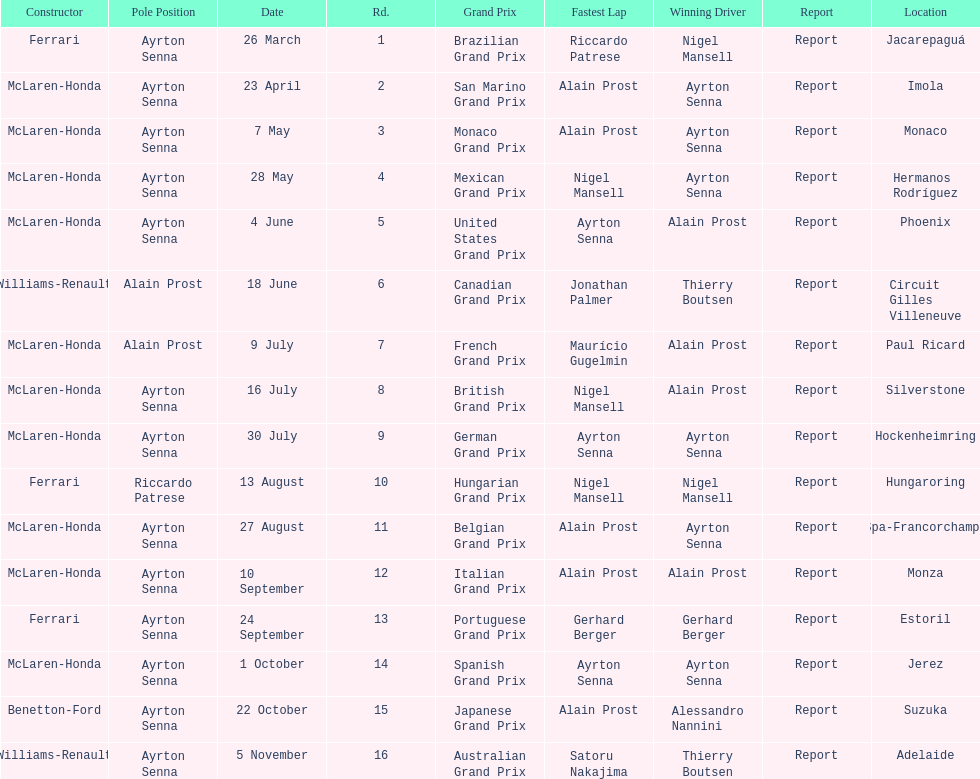Would you mind parsing the complete table? {'header': ['Constructor', 'Pole Position', 'Date', 'Rd.', 'Grand Prix', 'Fastest Lap', 'Winning Driver', 'Report', 'Location'], 'rows': [['Ferrari', 'Ayrton Senna', '26 March', '1', 'Brazilian Grand Prix', 'Riccardo Patrese', 'Nigel Mansell', 'Report', 'Jacarepaguá'], ['McLaren-Honda', 'Ayrton Senna', '23 April', '2', 'San Marino Grand Prix', 'Alain Prost', 'Ayrton Senna', 'Report', 'Imola'], ['McLaren-Honda', 'Ayrton Senna', '7 May', '3', 'Monaco Grand Prix', 'Alain Prost', 'Ayrton Senna', 'Report', 'Monaco'], ['McLaren-Honda', 'Ayrton Senna', '28 May', '4', 'Mexican Grand Prix', 'Nigel Mansell', 'Ayrton Senna', 'Report', 'Hermanos Rodríguez'], ['McLaren-Honda', 'Ayrton Senna', '4 June', '5', 'United States Grand Prix', 'Ayrton Senna', 'Alain Prost', 'Report', 'Phoenix'], ['Williams-Renault', 'Alain Prost', '18 June', '6', 'Canadian Grand Prix', 'Jonathan Palmer', 'Thierry Boutsen', 'Report', 'Circuit Gilles Villeneuve'], ['McLaren-Honda', 'Alain Prost', '9 July', '7', 'French Grand Prix', 'Maurício Gugelmin', 'Alain Prost', 'Report', 'Paul Ricard'], ['McLaren-Honda', 'Ayrton Senna', '16 July', '8', 'British Grand Prix', 'Nigel Mansell', 'Alain Prost', 'Report', 'Silverstone'], ['McLaren-Honda', 'Ayrton Senna', '30 July', '9', 'German Grand Prix', 'Ayrton Senna', 'Ayrton Senna', 'Report', 'Hockenheimring'], ['Ferrari', 'Riccardo Patrese', '13 August', '10', 'Hungarian Grand Prix', 'Nigel Mansell', 'Nigel Mansell', 'Report', 'Hungaroring'], ['McLaren-Honda', 'Ayrton Senna', '27 August', '11', 'Belgian Grand Prix', 'Alain Prost', 'Ayrton Senna', 'Report', 'Spa-Francorchamps'], ['McLaren-Honda', 'Ayrton Senna', '10 September', '12', 'Italian Grand Prix', 'Alain Prost', 'Alain Prost', 'Report', 'Monza'], ['Ferrari', 'Ayrton Senna', '24 September', '13', 'Portuguese Grand Prix', 'Gerhard Berger', 'Gerhard Berger', 'Report', 'Estoril'], ['McLaren-Honda', 'Ayrton Senna', '1 October', '14', 'Spanish Grand Prix', 'Ayrton Senna', 'Ayrton Senna', 'Report', 'Jerez'], ['Benetton-Ford', 'Ayrton Senna', '22 October', '15', 'Japanese Grand Prix', 'Alain Prost', 'Alessandro Nannini', 'Report', 'Suzuka'], ['Williams-Renault', 'Ayrton Senna', '5 November', '16', 'Australian Grand Prix', 'Satoru Nakajima', 'Thierry Boutsen', 'Report', 'Adelaide']]} Prost won the drivers title, who was his teammate? Ayrton Senna. 